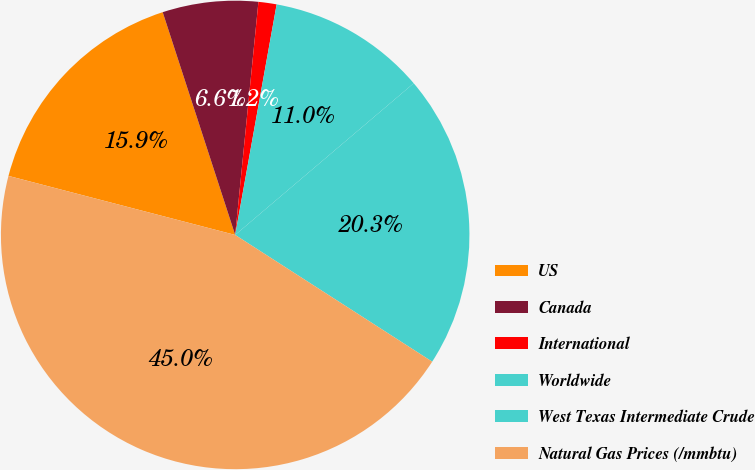Convert chart to OTSL. <chart><loc_0><loc_0><loc_500><loc_500><pie_chart><fcel>US<fcel>Canada<fcel>International<fcel>Worldwide<fcel>West Texas Intermediate Crude<fcel>Natural Gas Prices (/mmbtu)<nl><fcel>15.94%<fcel>6.59%<fcel>1.25%<fcel>10.96%<fcel>20.31%<fcel>44.96%<nl></chart> 